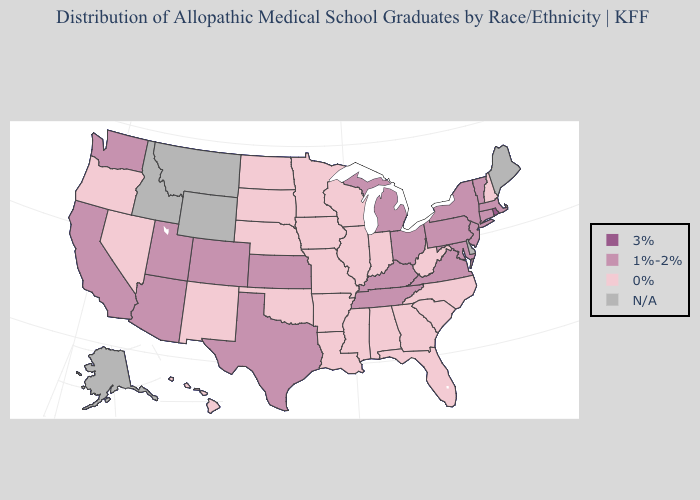Does the first symbol in the legend represent the smallest category?
Keep it brief. No. Which states have the lowest value in the USA?
Give a very brief answer. Alabama, Arkansas, Florida, Georgia, Hawaii, Illinois, Indiana, Iowa, Louisiana, Minnesota, Mississippi, Missouri, Nebraska, Nevada, New Hampshire, New Mexico, North Carolina, North Dakota, Oklahoma, Oregon, South Carolina, South Dakota, West Virginia, Wisconsin. Name the states that have a value in the range N/A?
Give a very brief answer. Alaska, Delaware, Idaho, Maine, Montana, Wyoming. What is the lowest value in the West?
Write a very short answer. 0%. What is the value of Iowa?
Concise answer only. 0%. What is the lowest value in states that border Louisiana?
Keep it brief. 0%. Among the states that border Oklahoma , which have the lowest value?
Quick response, please. Arkansas, Missouri, New Mexico. Does Oregon have the highest value in the USA?
Give a very brief answer. No. Name the states that have a value in the range N/A?
Be succinct. Alaska, Delaware, Idaho, Maine, Montana, Wyoming. How many symbols are there in the legend?
Quick response, please. 4. Name the states that have a value in the range 1%-2%?
Concise answer only. Arizona, California, Colorado, Connecticut, Kansas, Kentucky, Maryland, Massachusetts, Michigan, New Jersey, New York, Ohio, Pennsylvania, Tennessee, Texas, Utah, Vermont, Virginia, Washington. Is the legend a continuous bar?
Give a very brief answer. No. Which states hav the highest value in the Northeast?
Keep it brief. Rhode Island. 